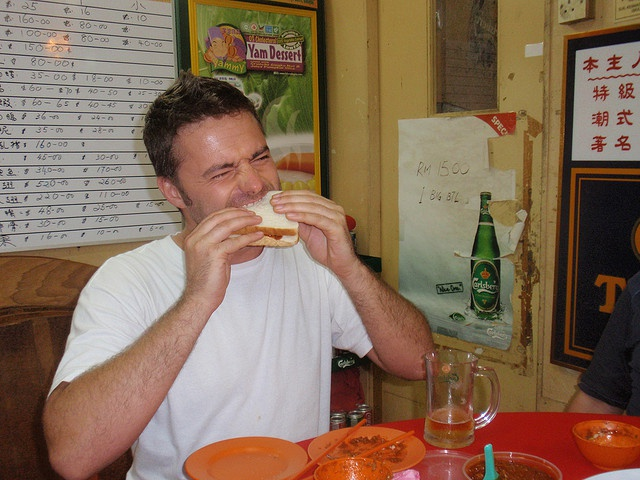Describe the objects in this image and their specific colors. I can see people in darkgray, brown, lightgray, and tan tones, dining table in darkgray, maroon, and brown tones, people in darkgray, black, maroon, and brown tones, cup in darkgray, maroon, and brown tones, and bowl in darkgray, brown, red, and maroon tones in this image. 